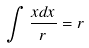Convert formula to latex. <formula><loc_0><loc_0><loc_500><loc_500>\int \frac { x d x } { r } = r</formula> 